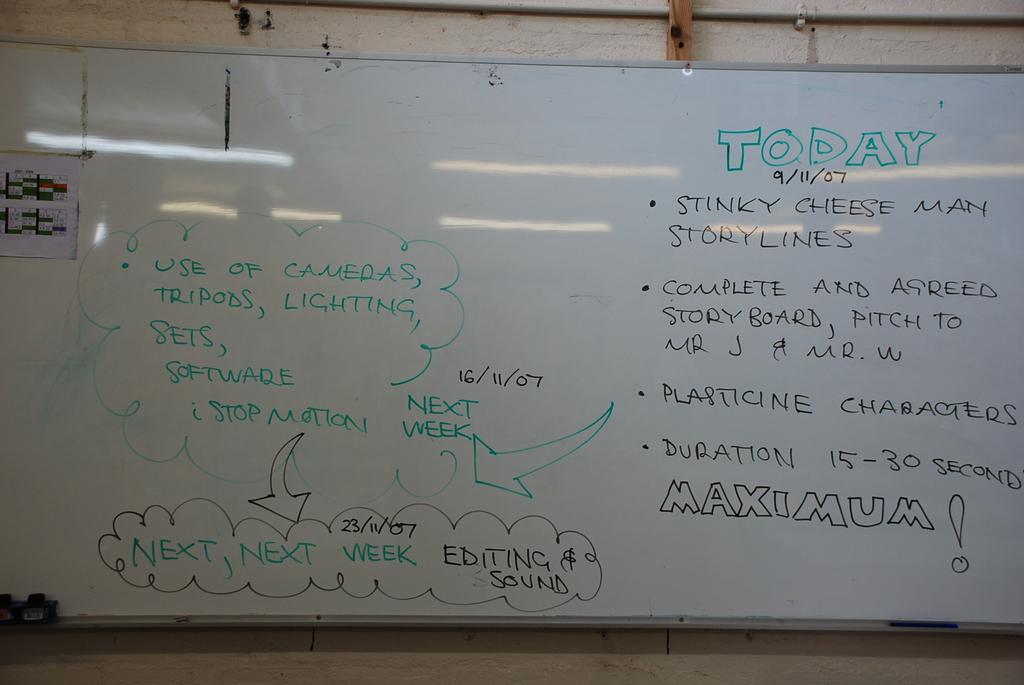What is today's date in this photo?
Provide a short and direct response. 9/11/07. What is the last word on the board?
Offer a very short reply. Maximum. 